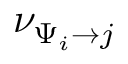Convert formula to latex. <formula><loc_0><loc_0><loc_500><loc_500>\nu _ { \Psi _ { i } \to j }</formula> 